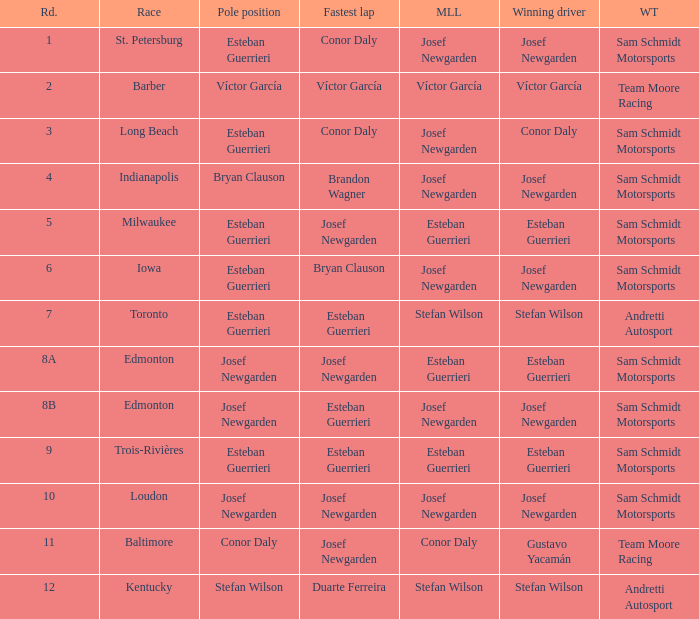Who had the fastest lap(s) when josef newgarden led the most laps at edmonton? Esteban Guerrieri. 